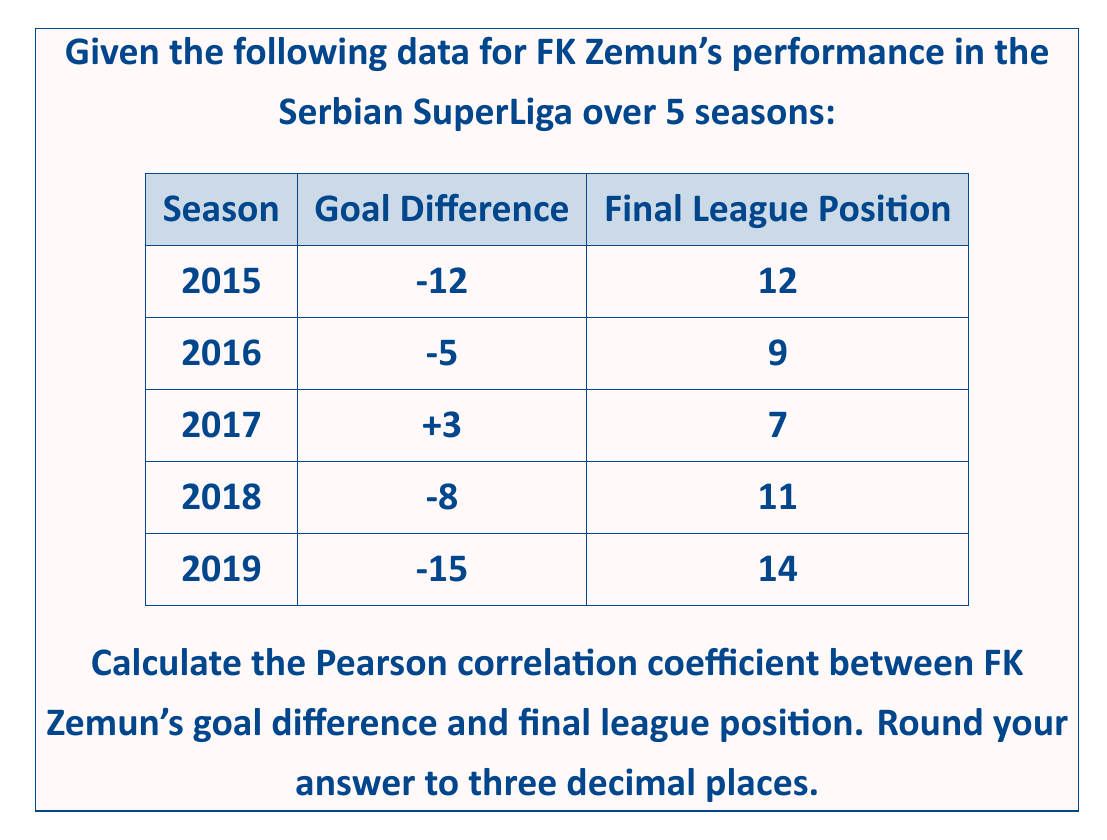What is the answer to this math problem? To calculate the Pearson correlation coefficient between FK Zemun's goal difference and final league position, we'll follow these steps:

1. Calculate the means of both variables:
   $\bar{x}$ (mean goal difference) = $(-12 - 5 + 3 - 8 - 15) / 5 = -7.4$
   $\bar{y}$ (mean league position) = $(12 + 9 + 7 + 11 + 14) / 5 = 10.6$

2. Calculate the deviations from the mean for each variable:
   $x_i - \bar{x}$ and $y_i - \bar{y}$

3. Calculate the products of these deviations and their sum:
   $\sum (x_i - \bar{x})(y_i - \bar{y})$

4. Calculate the sum of squared deviations for each variable:
   $\sum (x_i - \bar{x})^2$ and $\sum (y_i - \bar{y})^2$

5. Apply the Pearson correlation coefficient formula:

   $$r = \frac{\sum (x_i - \bar{x})(y_i - \bar{y})}{\sqrt{\sum (x_i - \bar{x})^2 \sum (y_i - \bar{y})^2}}$$

Calculations:

| $x_i$ | $y_i$ | $x_i - \bar{x}$ | $y_i - \bar{y}$ | $(x_i - \bar{x})(y_i - \bar{y})$ | $(x_i - \bar{x})^2$ | $(y_i - \bar{y})^2$ |
|-------|-------|-----------------|------------------|-----------------------------------|---------------------|---------------------|
| -12   | 12    | -4.6            | 1.4              | -6.44                             | 21.16               | 1.96                |
| -5    | 9     | 2.4             | -1.6             | -3.84                             | 5.76                | 2.56                |
| 3     | 7     | 10.4            | -3.6             | -37.44                            | 108.16              | 12.96               |
| -8    | 11    | -0.6            | 0.4              | -0.24                             | 0.36                | 0.16                |
| -15   | 14    | -7.6            | 3.4              | -25.84                            | 57.76               | 11.56               |

$\sum (x_i - \bar{x})(y_i - \bar{y}) = -73.8$
$\sum (x_i - \bar{x})^2 = 193.2$
$\sum (y_i - \bar{y})^2 = 29.2$

Now, we can apply the formula:

$$r = \frac{-73.8}{\sqrt{193.2 \times 29.2}} = \frac{-73.8}{75.0733} = -0.983$$

Rounding to three decimal places: $r = -0.983$
Answer: $-0.983$ 